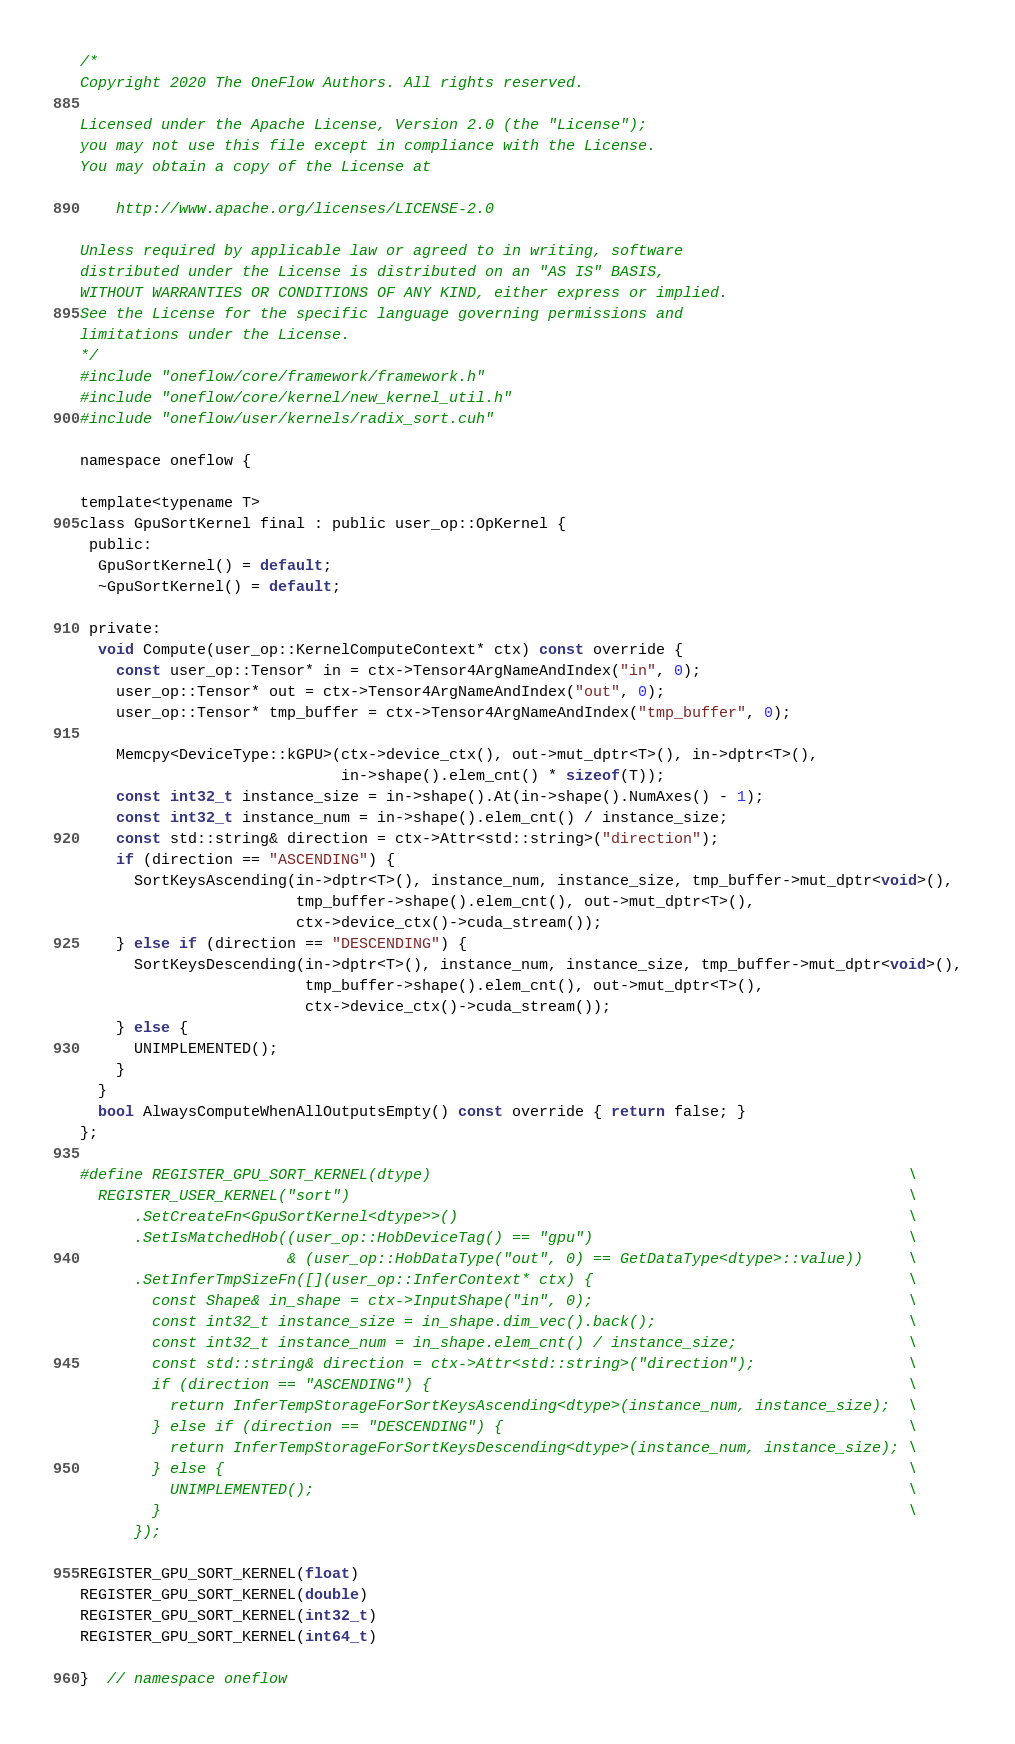Convert code to text. <code><loc_0><loc_0><loc_500><loc_500><_Cuda_>/*
Copyright 2020 The OneFlow Authors. All rights reserved.

Licensed under the Apache License, Version 2.0 (the "License");
you may not use this file except in compliance with the License.
You may obtain a copy of the License at

    http://www.apache.org/licenses/LICENSE-2.0

Unless required by applicable law or agreed to in writing, software
distributed under the License is distributed on an "AS IS" BASIS,
WITHOUT WARRANTIES OR CONDITIONS OF ANY KIND, either express or implied.
See the License for the specific language governing permissions and
limitations under the License.
*/
#include "oneflow/core/framework/framework.h"
#include "oneflow/core/kernel/new_kernel_util.h"
#include "oneflow/user/kernels/radix_sort.cuh"

namespace oneflow {

template<typename T>
class GpuSortKernel final : public user_op::OpKernel {
 public:
  GpuSortKernel() = default;
  ~GpuSortKernel() = default;

 private:
  void Compute(user_op::KernelComputeContext* ctx) const override {
    const user_op::Tensor* in = ctx->Tensor4ArgNameAndIndex("in", 0);
    user_op::Tensor* out = ctx->Tensor4ArgNameAndIndex("out", 0);
    user_op::Tensor* tmp_buffer = ctx->Tensor4ArgNameAndIndex("tmp_buffer", 0);

    Memcpy<DeviceType::kGPU>(ctx->device_ctx(), out->mut_dptr<T>(), in->dptr<T>(),
                             in->shape().elem_cnt() * sizeof(T));
    const int32_t instance_size = in->shape().At(in->shape().NumAxes() - 1);
    const int32_t instance_num = in->shape().elem_cnt() / instance_size;
    const std::string& direction = ctx->Attr<std::string>("direction");
    if (direction == "ASCENDING") {
      SortKeysAscending(in->dptr<T>(), instance_num, instance_size, tmp_buffer->mut_dptr<void>(),
                        tmp_buffer->shape().elem_cnt(), out->mut_dptr<T>(),
                        ctx->device_ctx()->cuda_stream());
    } else if (direction == "DESCENDING") {
      SortKeysDescending(in->dptr<T>(), instance_num, instance_size, tmp_buffer->mut_dptr<void>(),
                         tmp_buffer->shape().elem_cnt(), out->mut_dptr<T>(),
                         ctx->device_ctx()->cuda_stream());
    } else {
      UNIMPLEMENTED();
    }
  }
  bool AlwaysComputeWhenAllOutputsEmpty() const override { return false; }
};

#define REGISTER_GPU_SORT_KERNEL(dtype)                                                     \
  REGISTER_USER_KERNEL("sort")                                                              \
      .SetCreateFn<GpuSortKernel<dtype>>()                                                  \
      .SetIsMatchedHob((user_op::HobDeviceTag() == "gpu")                                   \
                       & (user_op::HobDataType("out", 0) == GetDataType<dtype>::value))     \
      .SetInferTmpSizeFn([](user_op::InferContext* ctx) {                                   \
        const Shape& in_shape = ctx->InputShape("in", 0);                                   \
        const int32_t instance_size = in_shape.dim_vec().back();                            \
        const int32_t instance_num = in_shape.elem_cnt() / instance_size;                   \
        const std::string& direction = ctx->Attr<std::string>("direction");                 \
        if (direction == "ASCENDING") {                                                     \
          return InferTempStorageForSortKeysAscending<dtype>(instance_num, instance_size);  \
        } else if (direction == "DESCENDING") {                                             \
          return InferTempStorageForSortKeysDescending<dtype>(instance_num, instance_size); \
        } else {                                                                            \
          UNIMPLEMENTED();                                                                  \
        }                                                                                   \
      });

REGISTER_GPU_SORT_KERNEL(float)
REGISTER_GPU_SORT_KERNEL(double)
REGISTER_GPU_SORT_KERNEL(int32_t)
REGISTER_GPU_SORT_KERNEL(int64_t)

}  // namespace oneflow
</code> 